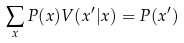Convert formula to latex. <formula><loc_0><loc_0><loc_500><loc_500>\sum _ { x } P ( x ) V ( x ^ { \prime } | x ) = P ( x ^ { \prime } )</formula> 